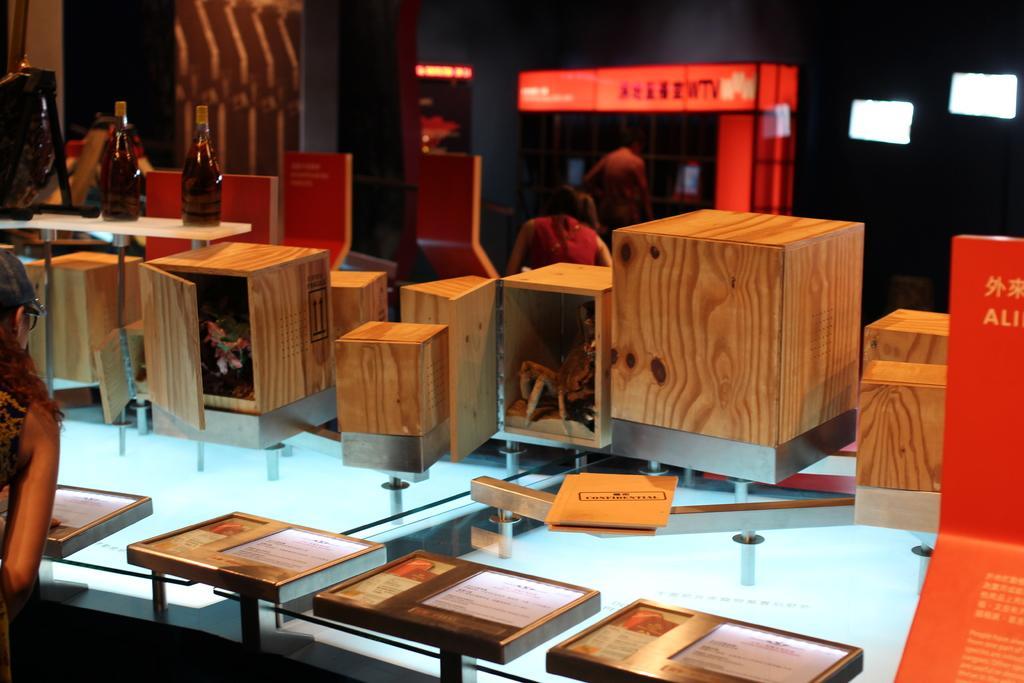Can you describe this image briefly? In this image I see a woman who is standing in front of table on which there are boxes and two bottle over here. In the background I see 2 more persons and the lights. 